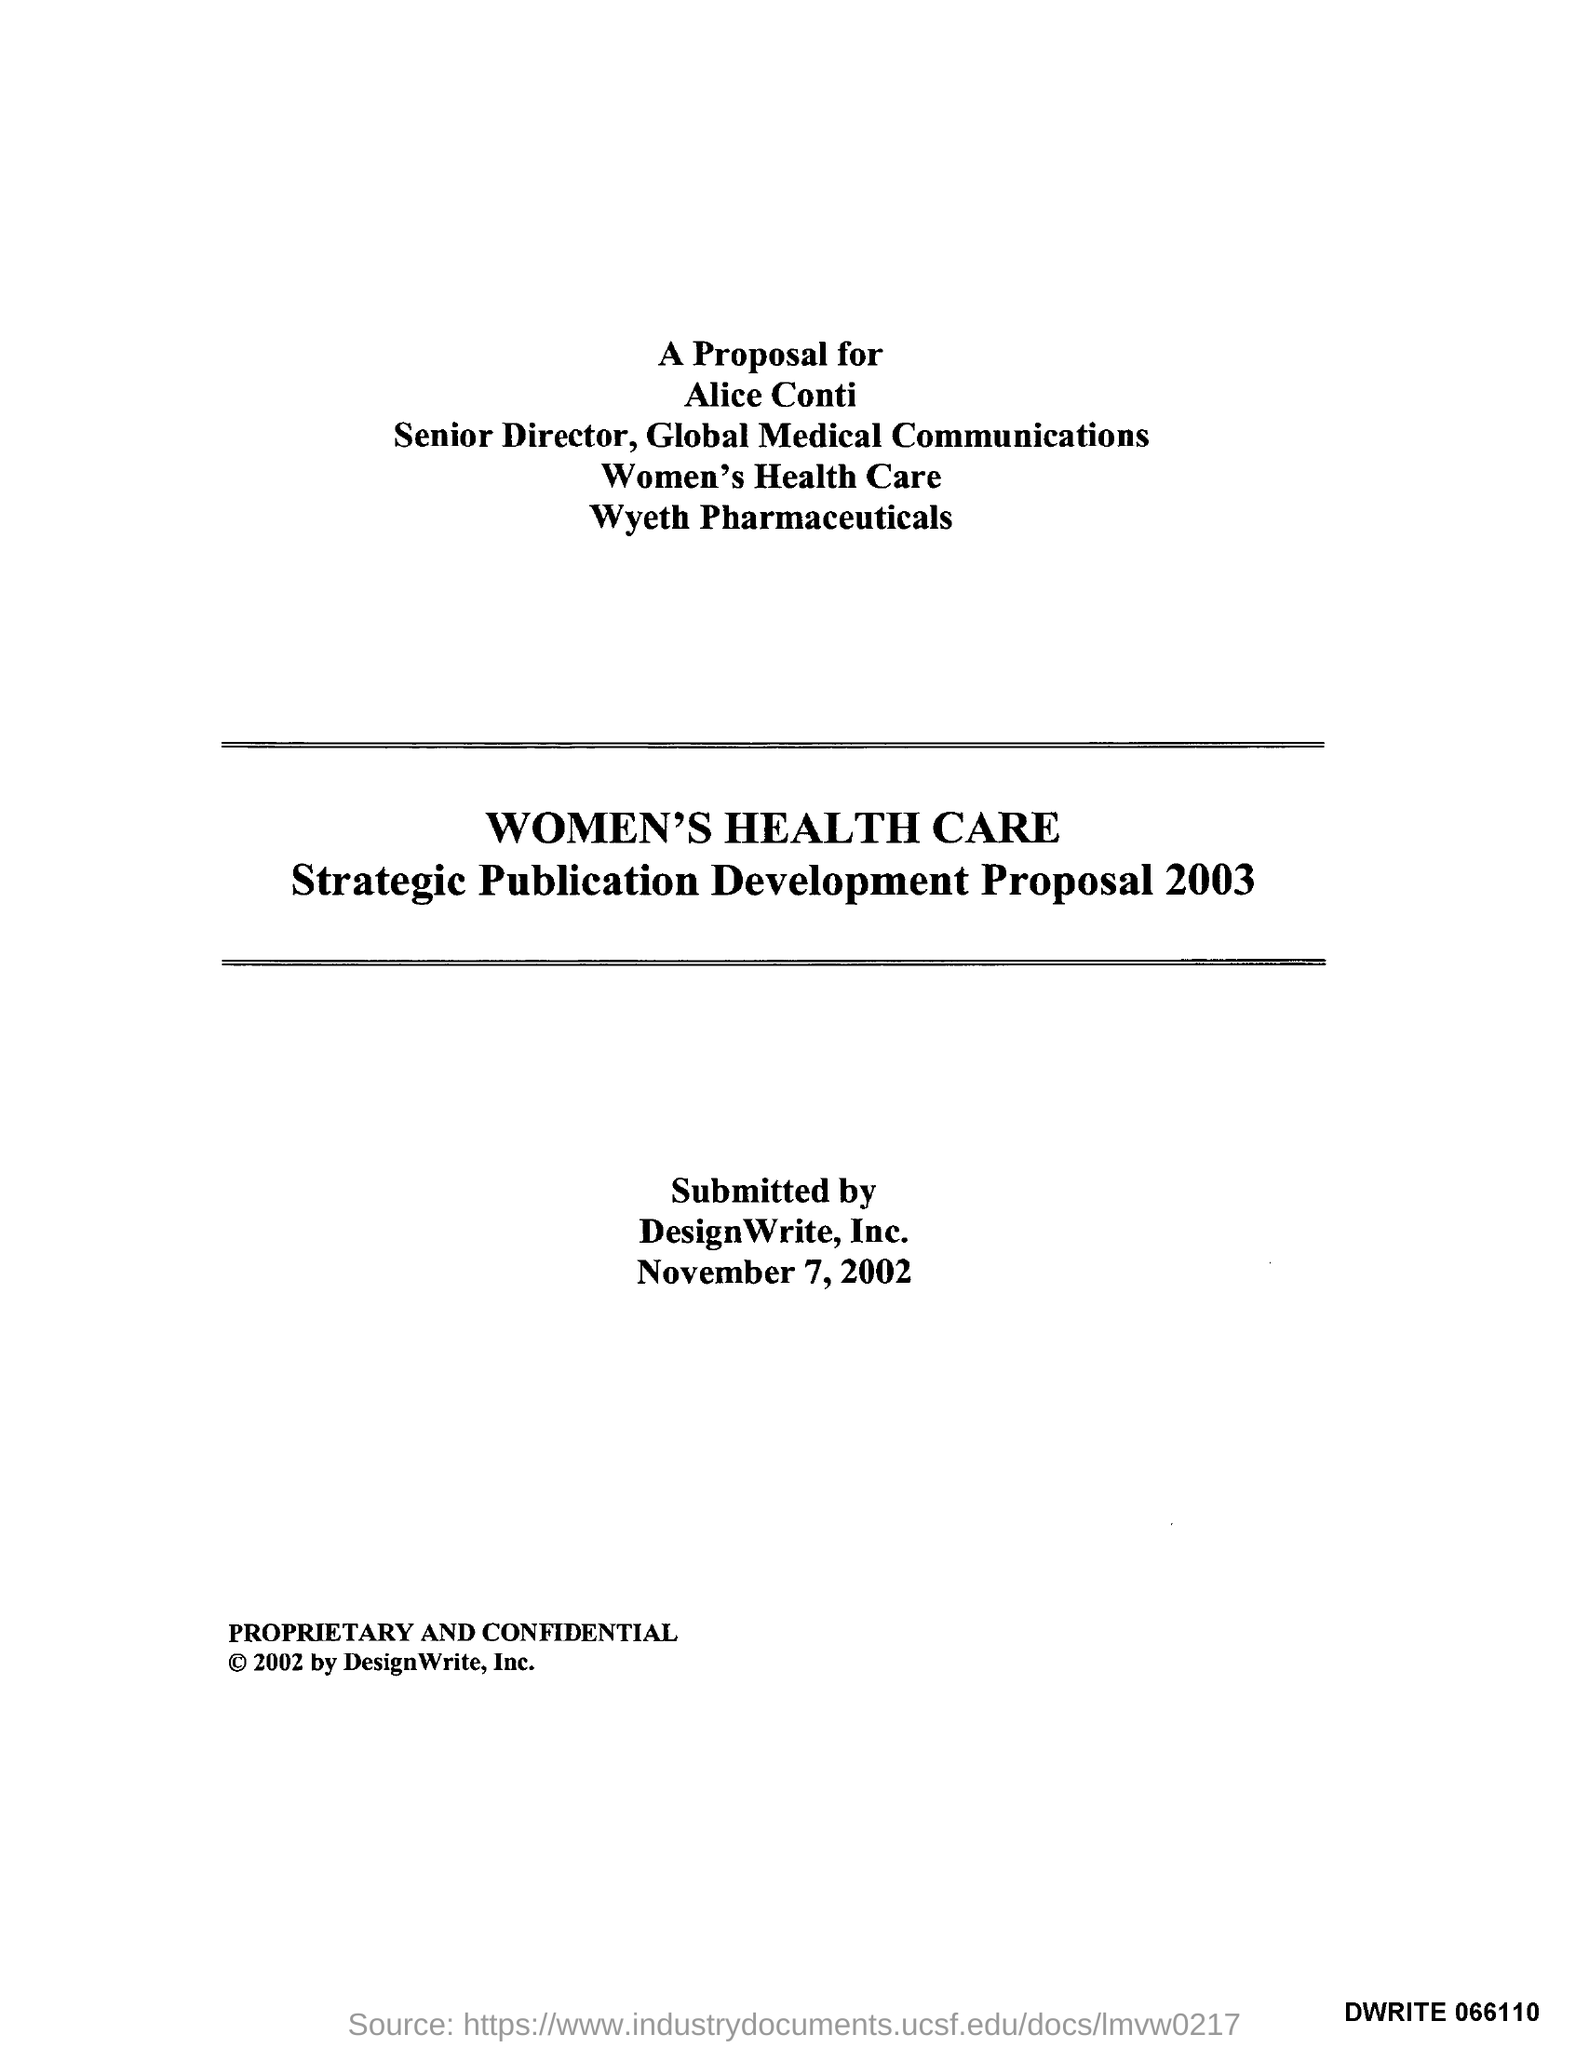What is the date on the document?
Ensure brevity in your answer.  November 7, 2002. 